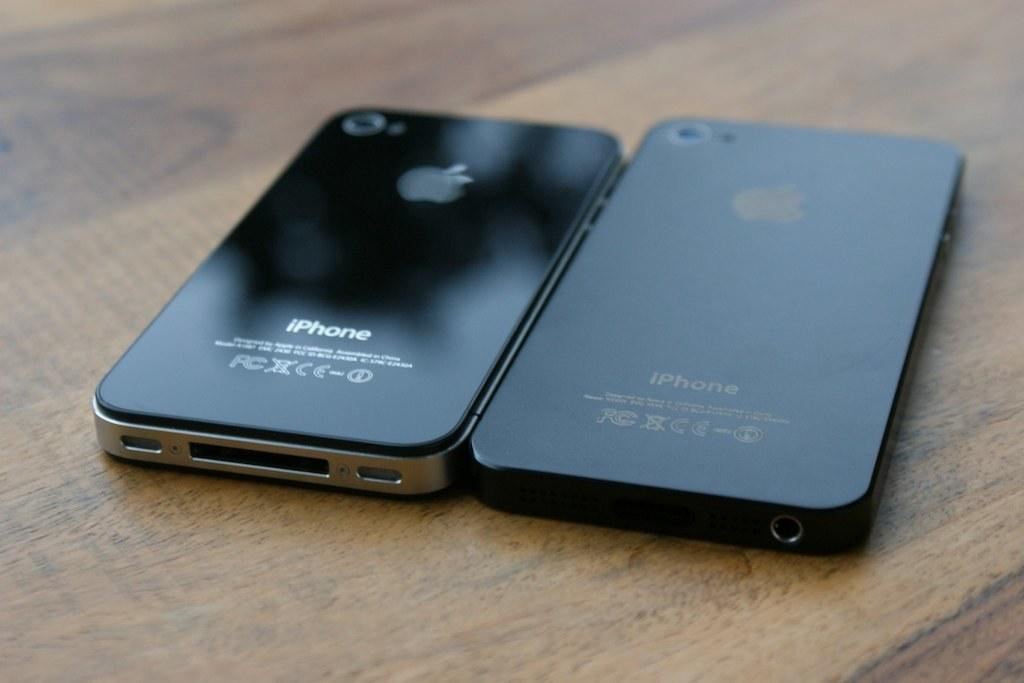Provide a one-sentence caption for the provided image. Two black iphones laid face down on a table. 